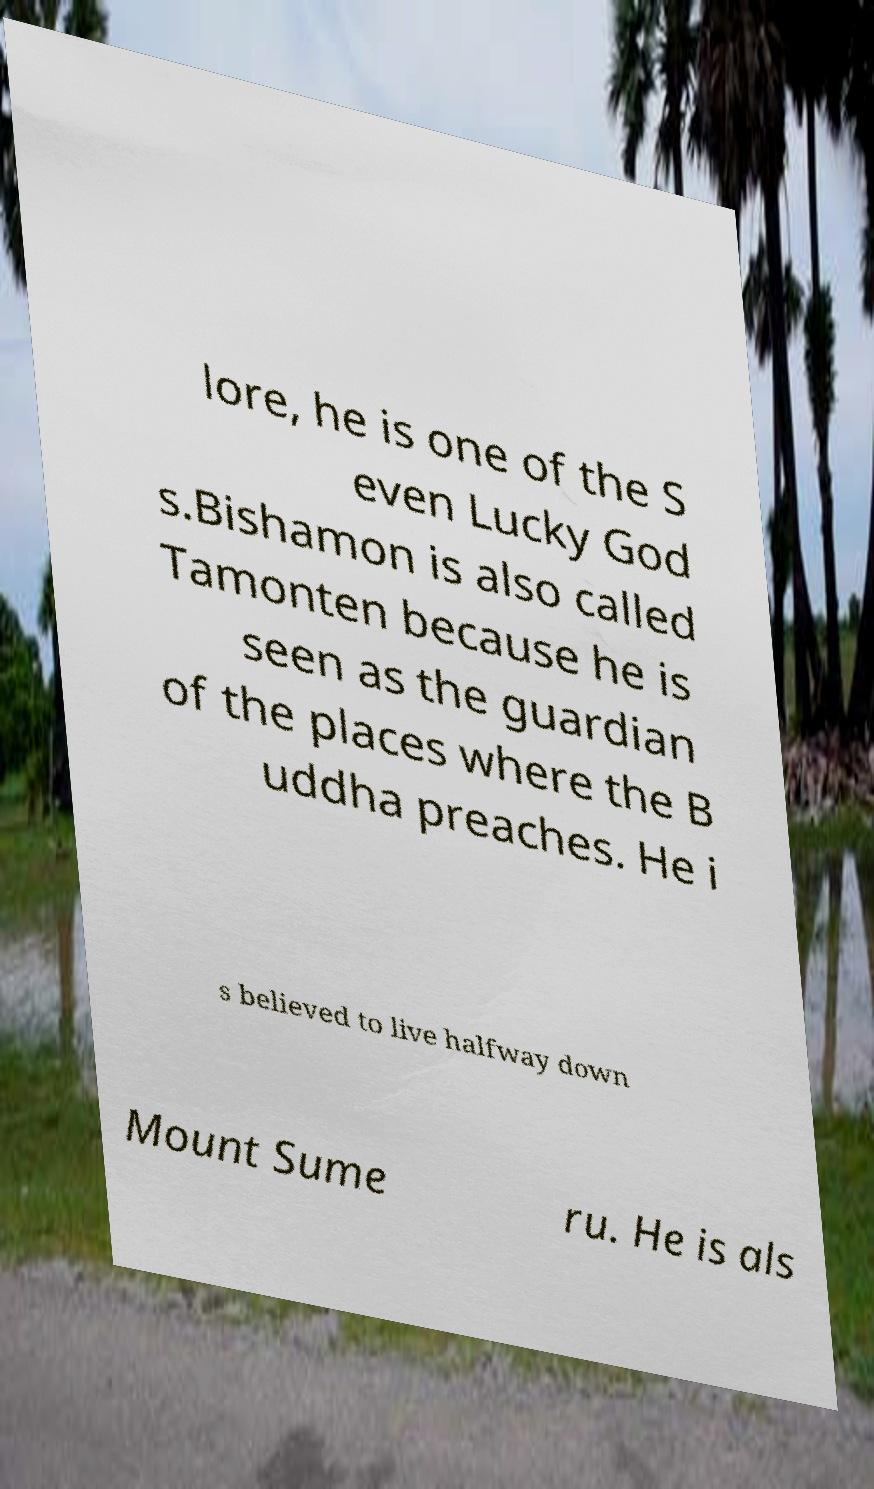Please identify and transcribe the text found in this image. lore, he is one of the S even Lucky God s.Bishamon is also called Tamonten because he is seen as the guardian of the places where the B uddha preaches. He i s believed to live halfway down Mount Sume ru. He is als 